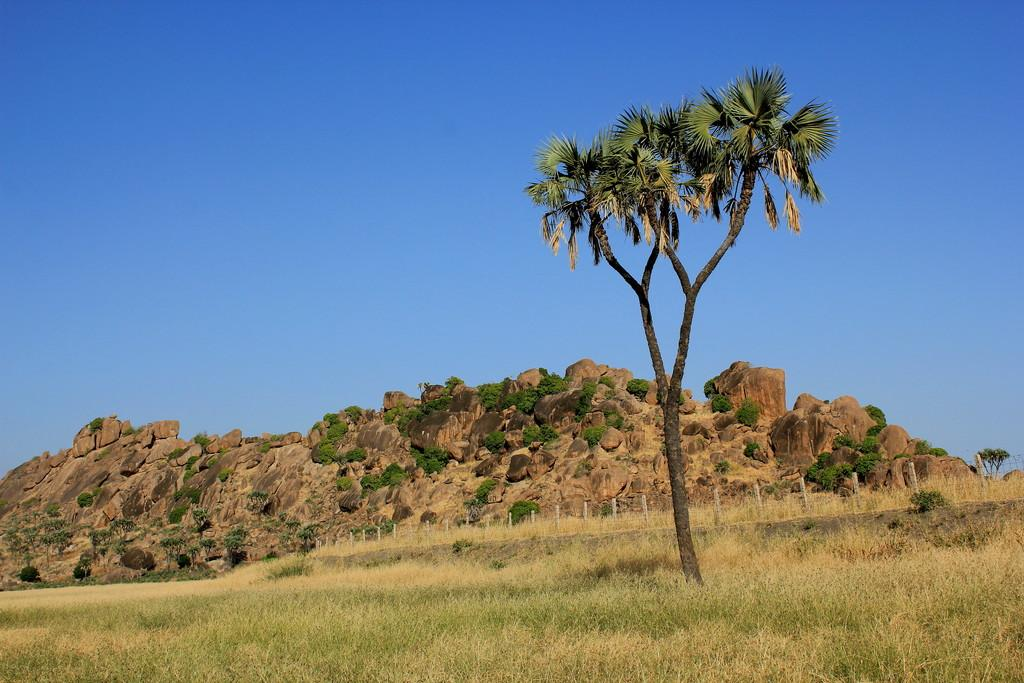What type of terrain is visible in the image? There is grassy land in the image. What structure can be seen in the image? There is a fence in the image. Are there any natural elements in the image? Yes, there is a tree and plants in the image. What geographical feature is visible in the distance? There is a mountain in the image. What is visible at the top of the image? The sky is visible at the top of the image. What type of company is conducting business in the image? There is no company or business activity present in the image. Can you describe the foggy conditions in the image? There is no fog present in the image; the sky is visible at the top. 